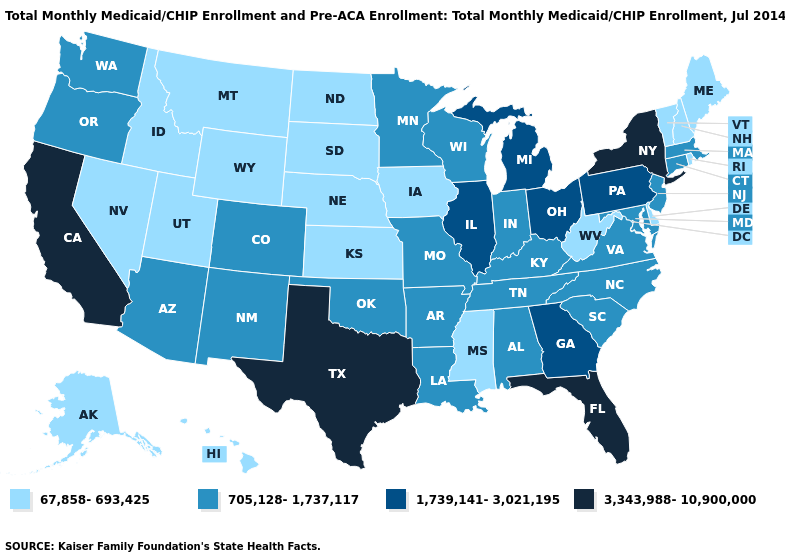Name the states that have a value in the range 67,858-693,425?
Write a very short answer. Alaska, Delaware, Hawaii, Idaho, Iowa, Kansas, Maine, Mississippi, Montana, Nebraska, Nevada, New Hampshire, North Dakota, Rhode Island, South Dakota, Utah, Vermont, West Virginia, Wyoming. Is the legend a continuous bar?
Be succinct. No. Which states have the lowest value in the USA?
Answer briefly. Alaska, Delaware, Hawaii, Idaho, Iowa, Kansas, Maine, Mississippi, Montana, Nebraska, Nevada, New Hampshire, North Dakota, Rhode Island, South Dakota, Utah, Vermont, West Virginia, Wyoming. Name the states that have a value in the range 705,128-1,737,117?
Keep it brief. Alabama, Arizona, Arkansas, Colorado, Connecticut, Indiana, Kentucky, Louisiana, Maryland, Massachusetts, Minnesota, Missouri, New Jersey, New Mexico, North Carolina, Oklahoma, Oregon, South Carolina, Tennessee, Virginia, Washington, Wisconsin. Name the states that have a value in the range 1,739,141-3,021,195?
Write a very short answer. Georgia, Illinois, Michigan, Ohio, Pennsylvania. Does the first symbol in the legend represent the smallest category?
Concise answer only. Yes. How many symbols are there in the legend?
Give a very brief answer. 4. Among the states that border Missouri , does Illinois have the highest value?
Quick response, please. Yes. Among the states that border Illinois , does Iowa have the highest value?
Keep it brief. No. Does Florida have the highest value in the USA?
Short answer required. Yes. Name the states that have a value in the range 67,858-693,425?
Short answer required. Alaska, Delaware, Hawaii, Idaho, Iowa, Kansas, Maine, Mississippi, Montana, Nebraska, Nevada, New Hampshire, North Dakota, Rhode Island, South Dakota, Utah, Vermont, West Virginia, Wyoming. What is the value of Missouri?
Write a very short answer. 705,128-1,737,117. Among the states that border Indiana , does Kentucky have the highest value?
Write a very short answer. No. Does the first symbol in the legend represent the smallest category?
Keep it brief. Yes. What is the lowest value in the USA?
Be succinct. 67,858-693,425. 